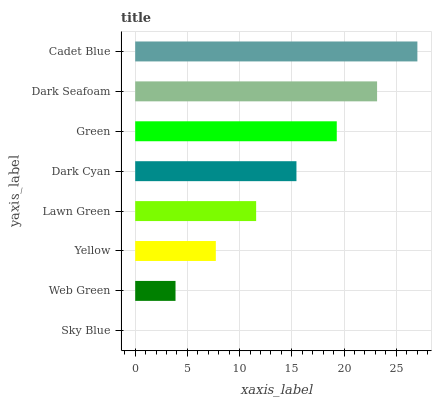Is Sky Blue the minimum?
Answer yes or no. Yes. Is Cadet Blue the maximum?
Answer yes or no. Yes. Is Web Green the minimum?
Answer yes or no. No. Is Web Green the maximum?
Answer yes or no. No. Is Web Green greater than Sky Blue?
Answer yes or no. Yes. Is Sky Blue less than Web Green?
Answer yes or no. Yes. Is Sky Blue greater than Web Green?
Answer yes or no. No. Is Web Green less than Sky Blue?
Answer yes or no. No. Is Dark Cyan the high median?
Answer yes or no. Yes. Is Lawn Green the low median?
Answer yes or no. Yes. Is Sky Blue the high median?
Answer yes or no. No. Is Cadet Blue the low median?
Answer yes or no. No. 